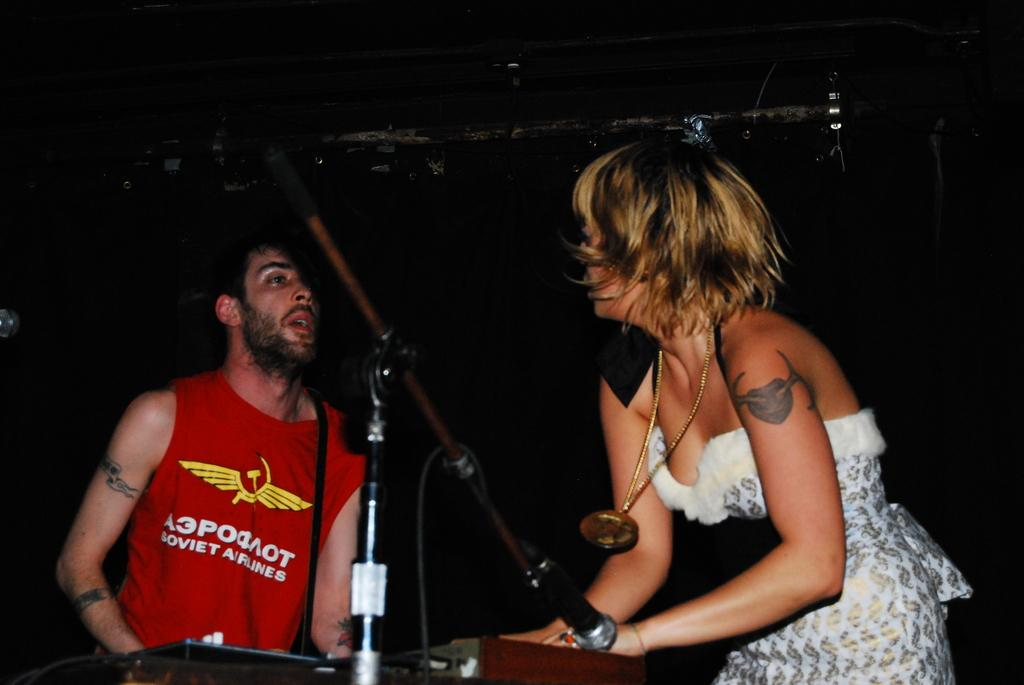Who are the people in the image? There is a man and a lady in the image. What is the man holding in the image? The man is holding a mic stand in the image. What else can be seen in the image besides the people? There are musical instruments in the image. Can you see a tiger smiling in the image? No, there is no tiger present in the image, and therefore no one is smiling. 